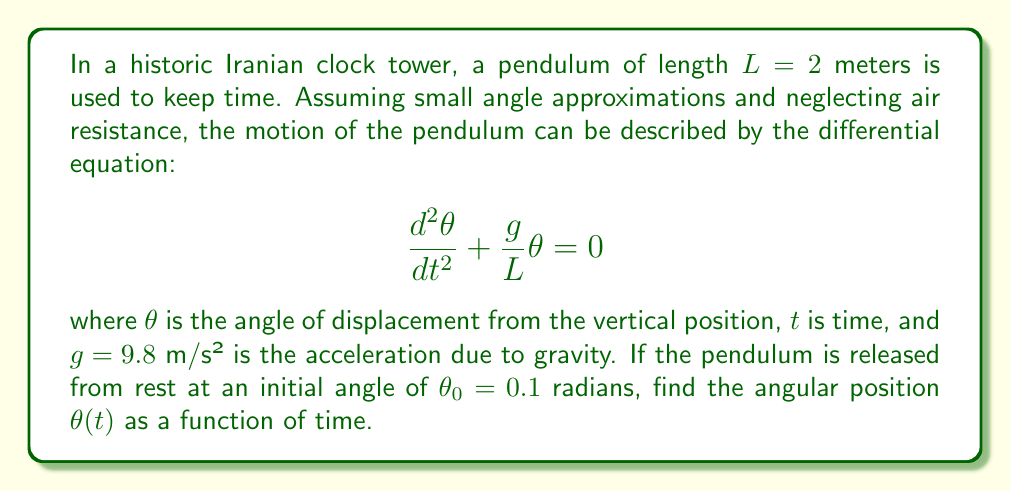Could you help me with this problem? To solve this differential equation, we follow these steps:

1) First, we recognize this as a second-order linear homogeneous differential equation with constant coefficients. The general solution for such an equation is:

   $$\theta(t) = A\cos(\omega t) + B\sin(\omega t)$$

   where $\omega = \sqrt{\frac{g}{L}}$ is the angular frequency of the pendulum.

2) Calculate $\omega$:
   $$\omega = \sqrt{\frac{g}{L}} = \sqrt{\frac{9.8}{2}} = \sqrt{4.9} \approx 2.21 \text{ rad/s}$$

3) We need to find the constants $A$ and $B$ using the initial conditions:
   - At $t = 0$, $\theta(0) = \theta_0 = 0.1$
   - At $t = 0$, $\frac{d\theta}{dt}(0) = 0$ (released from rest)

4) Using the first condition:
   $$\theta(0) = A\cos(0) + B\sin(0) = A = 0.1$$

5) Using the second condition:
   $$\frac{d\theta}{dt} = -A\omega\sin(\omega t) + B\omega\cos(\omega t)$$
   $$\frac{d\theta}{dt}(0) = B\omega = 0$$
   $$B = 0$$

6) Therefore, the solution is:
   $$\theta(t) = 0.1\cos(2.21t)$$
Answer: $$\theta(t) = 0.1\cos(2.21t)$$ 